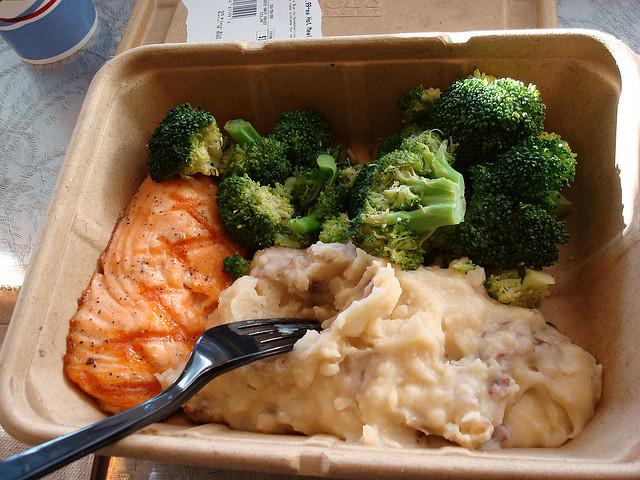Is there meat in the box?
Short answer required. No. What is the green food?
Keep it brief. Broccoli. How would a nutritionist rate this meal?
Keep it brief. Healthy. 